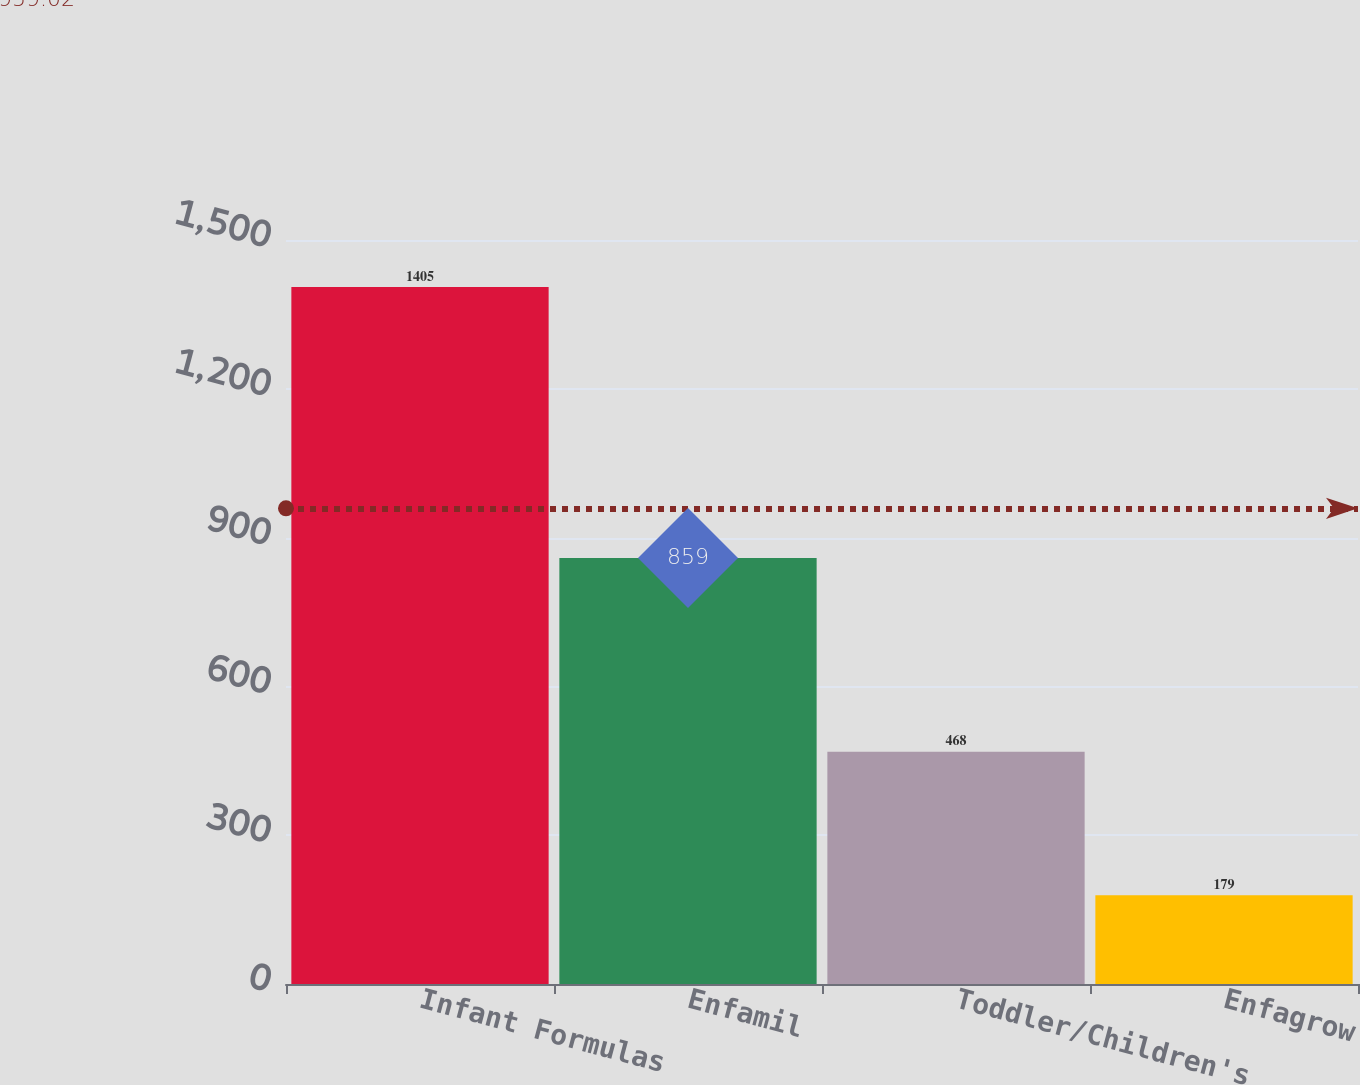<chart> <loc_0><loc_0><loc_500><loc_500><bar_chart><fcel>Infant Formulas<fcel>Enfamil<fcel>Toddler/Children's<fcel>Enfagrow<nl><fcel>1405<fcel>859<fcel>468<fcel>179<nl></chart> 